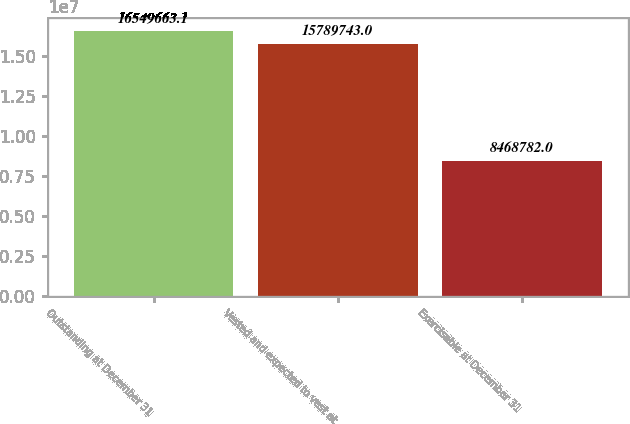<chart> <loc_0><loc_0><loc_500><loc_500><bar_chart><fcel>Outstanding at December 31<fcel>Vested and expected to vest at<fcel>Exercisable at December 31<nl><fcel>1.65497e+07<fcel>1.57897e+07<fcel>8.46878e+06<nl></chart> 